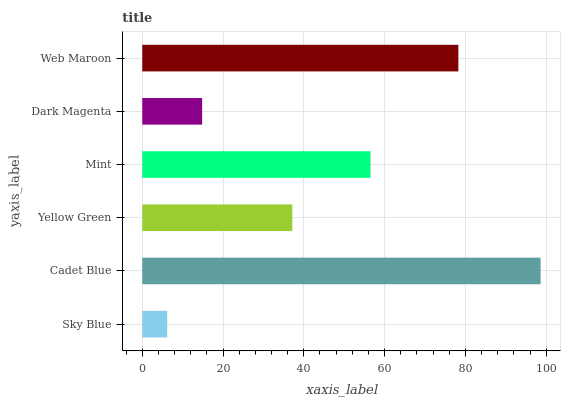Is Sky Blue the minimum?
Answer yes or no. Yes. Is Cadet Blue the maximum?
Answer yes or no. Yes. Is Yellow Green the minimum?
Answer yes or no. No. Is Yellow Green the maximum?
Answer yes or no. No. Is Cadet Blue greater than Yellow Green?
Answer yes or no. Yes. Is Yellow Green less than Cadet Blue?
Answer yes or no. Yes. Is Yellow Green greater than Cadet Blue?
Answer yes or no. No. Is Cadet Blue less than Yellow Green?
Answer yes or no. No. Is Mint the high median?
Answer yes or no. Yes. Is Yellow Green the low median?
Answer yes or no. Yes. Is Dark Magenta the high median?
Answer yes or no. No. Is Mint the low median?
Answer yes or no. No. 